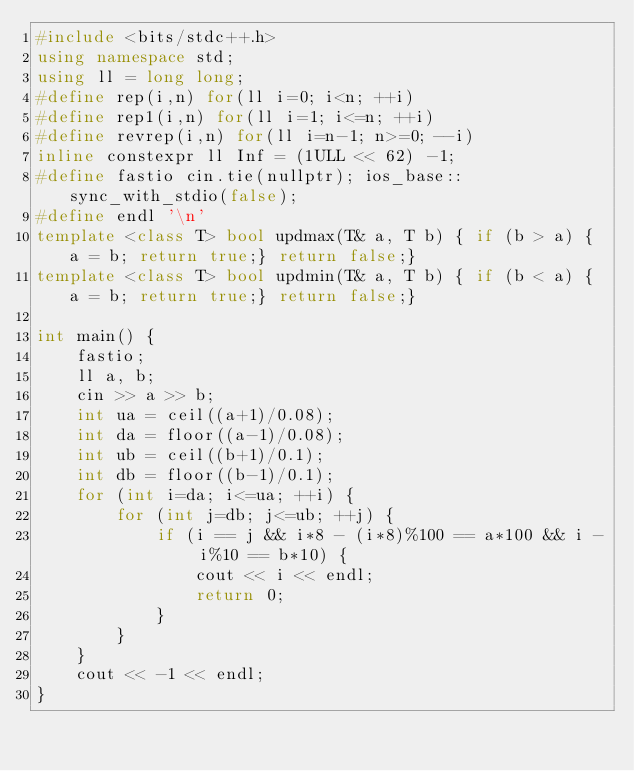<code> <loc_0><loc_0><loc_500><loc_500><_C++_>#include <bits/stdc++.h>
using namespace std;
using ll = long long;
#define rep(i,n) for(ll i=0; i<n; ++i)
#define rep1(i,n) for(ll i=1; i<=n; ++i)
#define revrep(i,n) for(ll i=n-1; n>=0; --i)
inline constexpr ll Inf = (1ULL << 62) -1;
#define fastio cin.tie(nullptr); ios_base::sync_with_stdio(false);
#define endl '\n'
template <class T> bool updmax(T& a, T b) { if (b > a) { a = b; return true;} return false;}
template <class T> bool updmin(T& a, T b) { if (b < a) { a = b; return true;} return false;}

int main() {
    fastio;
    ll a, b;
    cin >> a >> b;
    int ua = ceil((a+1)/0.08);
    int da = floor((a-1)/0.08);
    int ub = ceil((b+1)/0.1);
    int db = floor((b-1)/0.1);
    for (int i=da; i<=ua; ++i) {
        for (int j=db; j<=ub; ++j) {
            if (i == j && i*8 - (i*8)%100 == a*100 && i - i%10 == b*10) {
                cout << i << endl;
                return 0;
            }
        }
    }
    cout << -1 << endl;
}
</code> 